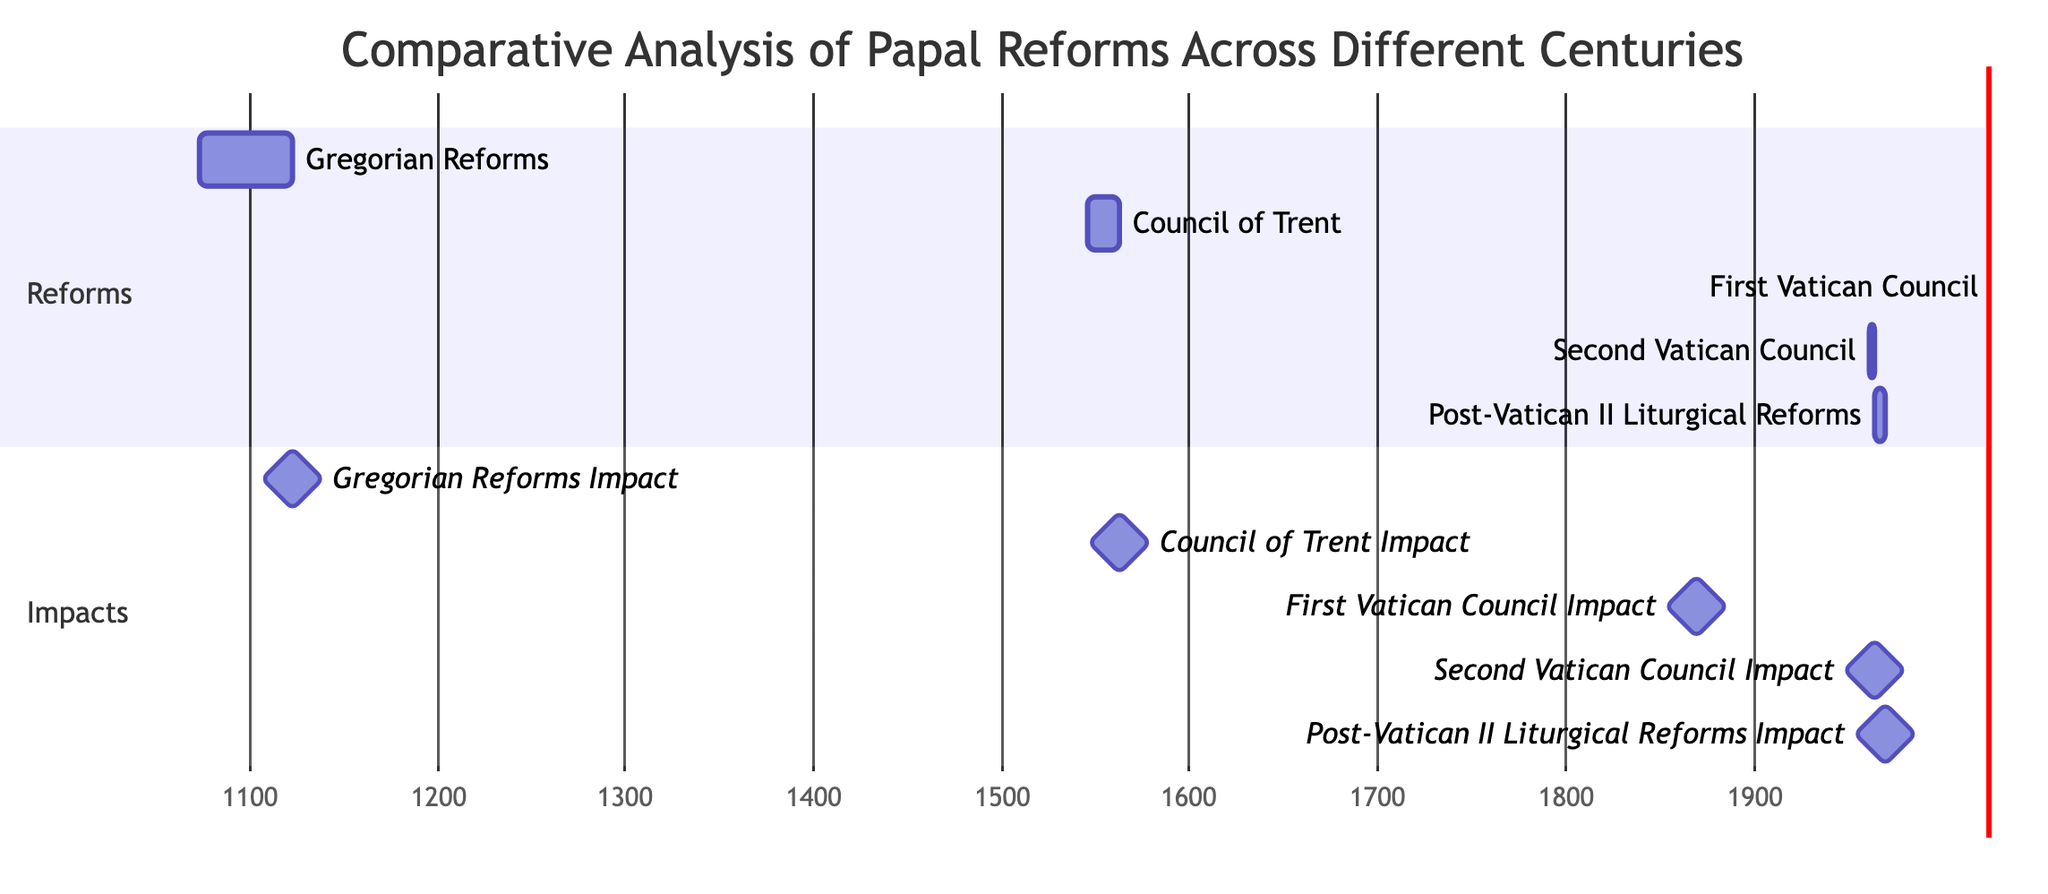What are the initiation dates of the reforms? The diagram indicates the initiation dates for each reform, which are: Gregorian Reforms in 1073, Council of Trent in 1545, First Vatican Council in 1869, Second Vatican Council in 1962, and Post-Vatican II Liturgical Reforms in 1965.
Answer: 1073, 1545, 1869, 1962, 1965 How many years did the Second Vatican Council last? The duration of the Second Vatican Council is represented in the diagram by the length of the bar, indicating it lasted from 1962 to 1965, which totals to 3 years.
Answer: 3 years Which reform has the earliest impact date? By examining the milestones in the diagram, the Gregorian Reforms have the earliest impact date of 1122, occurring before the impact dates of the other reforms.
Answer: 1122 What is the total duration of the post-Vatican II liturgical reforms? The duration of the post-Vatican II liturgical reforms is indicated in the diagram as spanning from 1965 to 1970, totaling 5 years, which is also represented by the length of the bar.
Answer: 5 years How many reforms were initiated in the 20th century? Looking at the initiation dates, two reforms, the Second Vatican Council and the Post-Vatican II Liturgical Reforms, were initiated in the 20th century (1962 and 1965 respectively).
Answer: 2 reforms Which reform corresponds to the longest duration among the listed reforms? After assessing the lengths of the bars in the diagram, the Gregorian Reforms, which lasted for 49 years from 1073 to 1122, represent the longest duration among all reforms.
Answer: 49 years When did the Council of Trent conclude? The diagram shows that the Council of Trent had an impact date of 1563, indicating the year it concluded. This is directly labeled in the milestones section of the Gantt chart.
Answer: 1563 Which reform is associated with the dogma of papal infallibility? Based on the description in the diagram, the First Vatican Council, initiated in 1869, is specifically associated with defining the dogma of papal infallibility.
Answer: First Vatican Council 